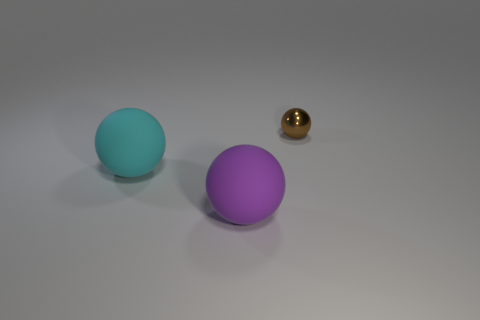Can you guess the lighting direction in this scene? Observing the shadows and highlights on the objects, it seems the primary light source is above and slightly to the right of the scene, casting diffuse shadows to the lower left of each object, indicating a soft, possibly overhead lighting environment. 